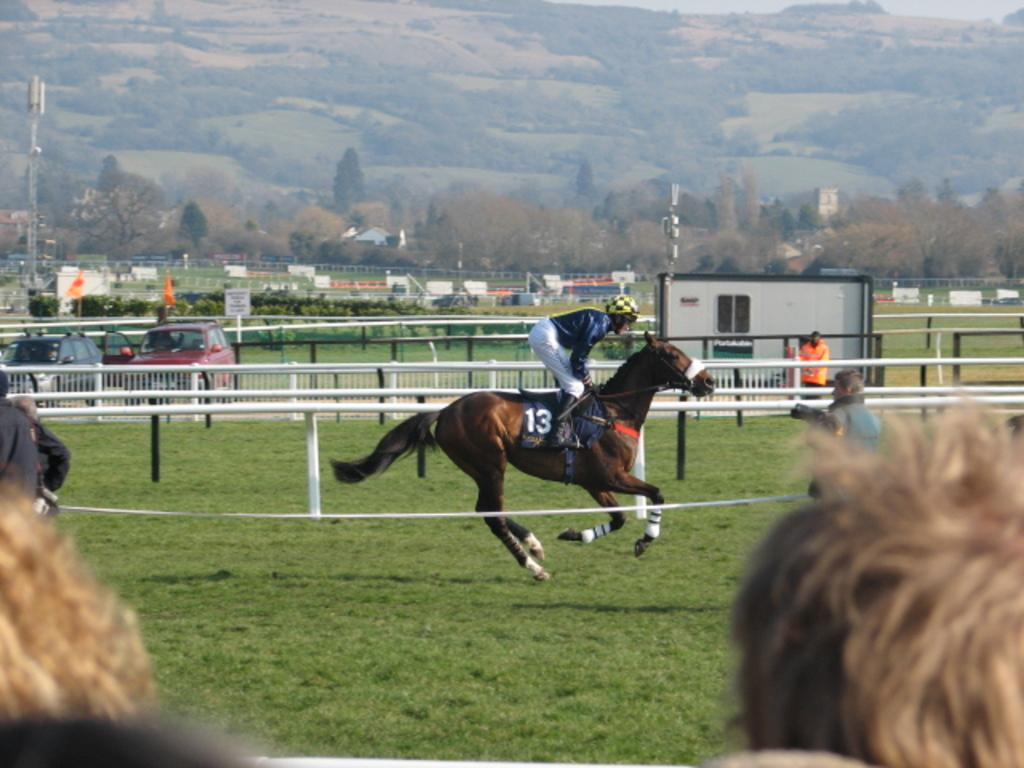What is the main subject of the image? There is a person riding a horse in the image. What type of terrain can be seen in the image? There is grass visible in the image. How many other persons are present in the image? There are other persons in the image. What type of vehicles are present in the image? Cars are present in the image. What type of barrier is visible in the image? There is a fence in the image. What type of vegetation is visible in the image? Plants and trees are visible in the image. What type of signage is present in the image? Boards are present in the image. How many cacti are visible in the image? There are no cacti visible in the image. What type of fuel is being used by the person riding the horse in the image? The image does not provide information about the type of fuel being used by the person riding the horse. 